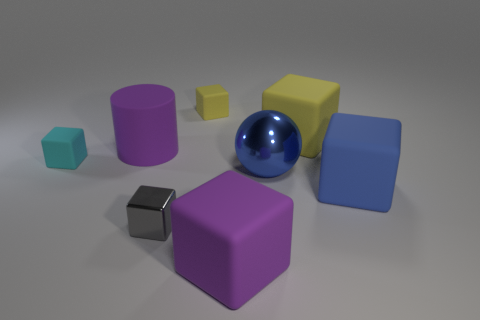Subtract all yellow blocks. How many blocks are left? 4 Add 1 blocks. How many objects exist? 9 Subtract 1 cylinders. How many cylinders are left? 0 Subtract all purple cubes. How many cubes are left? 5 Subtract all cylinders. How many objects are left? 7 Subtract all purple balls. Subtract all cyan cylinders. How many balls are left? 1 Subtract all green cylinders. How many purple cubes are left? 1 Subtract all tiny metal balls. Subtract all cyan cubes. How many objects are left? 7 Add 2 big purple rubber blocks. How many big purple rubber blocks are left? 3 Add 7 small red matte spheres. How many small red matte spheres exist? 7 